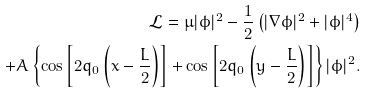<formula> <loc_0><loc_0><loc_500><loc_500>\mathcal { L } = \mu | \phi | ^ { 2 } - \frac { 1 } { 2 } \left ( | \nabla \phi | ^ { 2 } + | \phi | ^ { 4 } \right ) \\ + A \left \{ \cos \left [ 2 q _ { 0 } \left ( x - \frac { L } { 2 } \right ) \right ] + \cos \left [ 2 q _ { 0 } \left ( y - \frac { L } { 2 } \right ) \right ] \right \} | \phi | ^ { 2 } .</formula> 